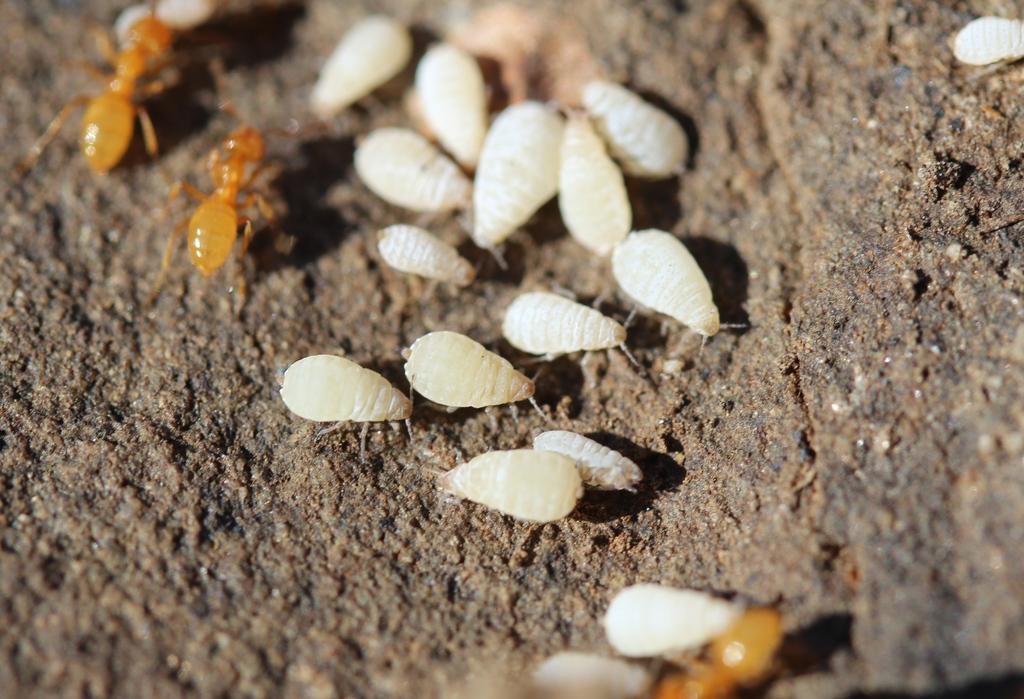How would you summarize this image in a sentence or two? In this image there are small insects on the stone. 